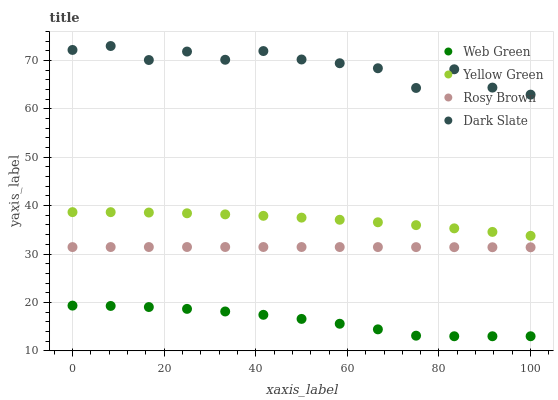Does Web Green have the minimum area under the curve?
Answer yes or no. Yes. Does Dark Slate have the maximum area under the curve?
Answer yes or no. Yes. Does Rosy Brown have the minimum area under the curve?
Answer yes or no. No. Does Rosy Brown have the maximum area under the curve?
Answer yes or no. No. Is Rosy Brown the smoothest?
Answer yes or no. Yes. Is Dark Slate the roughest?
Answer yes or no. Yes. Is Yellow Green the smoothest?
Answer yes or no. No. Is Yellow Green the roughest?
Answer yes or no. No. Does Web Green have the lowest value?
Answer yes or no. Yes. Does Rosy Brown have the lowest value?
Answer yes or no. No. Does Dark Slate have the highest value?
Answer yes or no. Yes. Does Rosy Brown have the highest value?
Answer yes or no. No. Is Yellow Green less than Dark Slate?
Answer yes or no. Yes. Is Dark Slate greater than Yellow Green?
Answer yes or no. Yes. Does Yellow Green intersect Dark Slate?
Answer yes or no. No. 